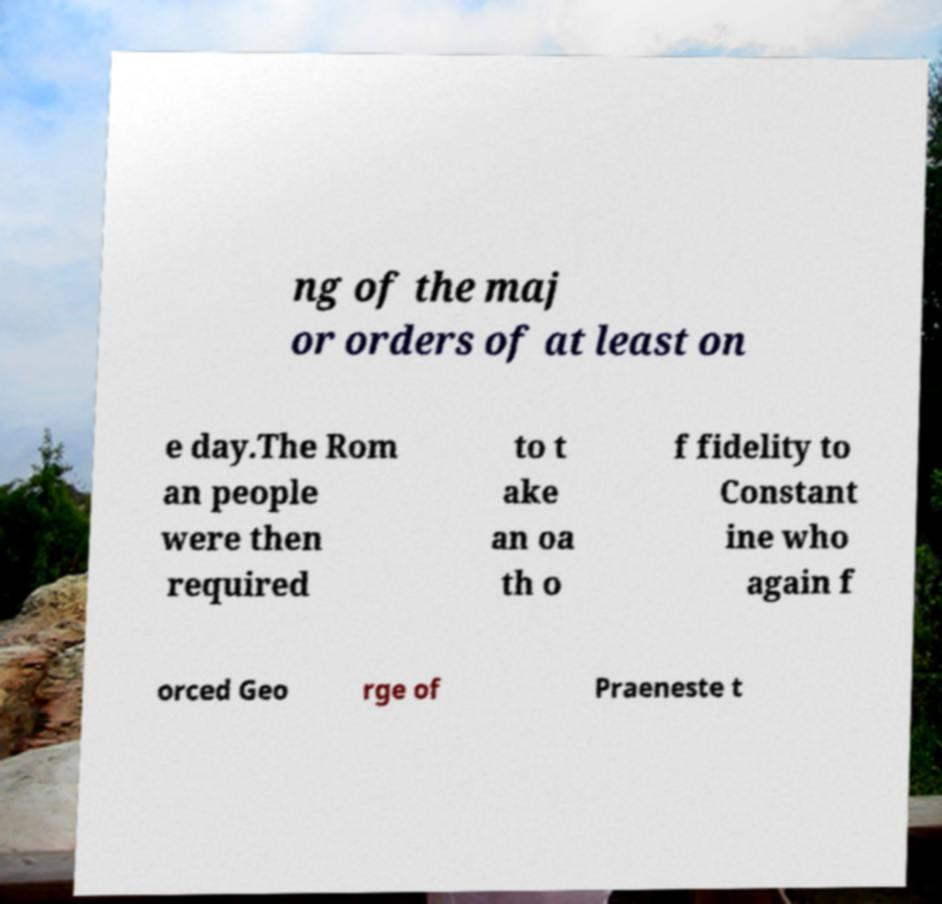Can you read and provide the text displayed in the image?This photo seems to have some interesting text. Can you extract and type it out for me? ng of the maj or orders of at least on e day.The Rom an people were then required to t ake an oa th o f fidelity to Constant ine who again f orced Geo rge of Praeneste t 